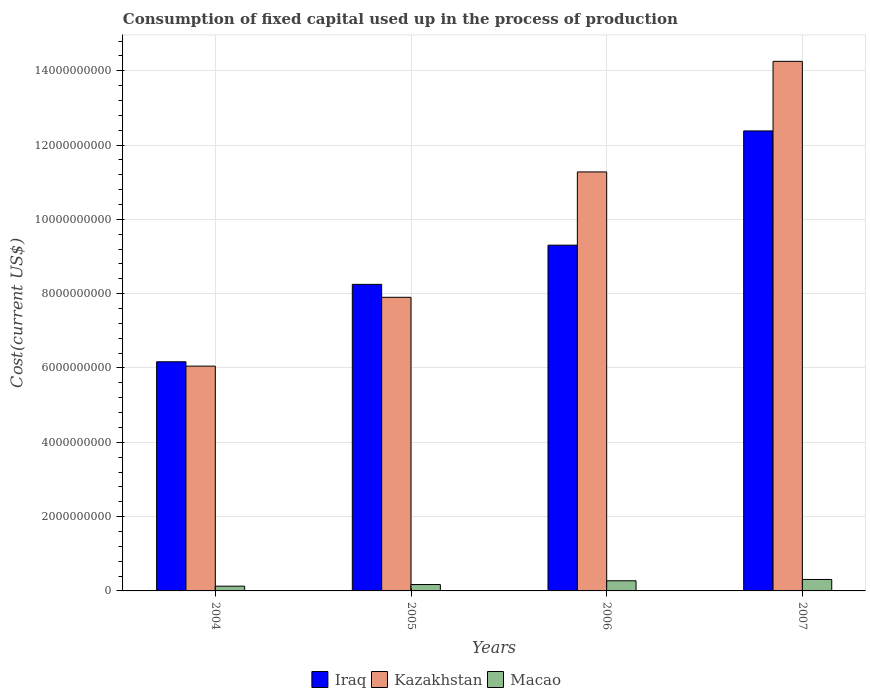How many different coloured bars are there?
Provide a short and direct response. 3. How many groups of bars are there?
Give a very brief answer. 4. How many bars are there on the 1st tick from the left?
Your answer should be compact. 3. How many bars are there on the 2nd tick from the right?
Provide a succinct answer. 3. What is the label of the 1st group of bars from the left?
Your answer should be very brief. 2004. What is the amount consumed in the process of production in Iraq in 2005?
Offer a terse response. 8.25e+09. Across all years, what is the maximum amount consumed in the process of production in Iraq?
Your response must be concise. 1.24e+1. Across all years, what is the minimum amount consumed in the process of production in Macao?
Make the answer very short. 1.28e+08. What is the total amount consumed in the process of production in Kazakhstan in the graph?
Your answer should be very brief. 3.95e+1. What is the difference between the amount consumed in the process of production in Macao in 2005 and that in 2007?
Your answer should be compact. -1.37e+08. What is the difference between the amount consumed in the process of production in Macao in 2006 and the amount consumed in the process of production in Kazakhstan in 2004?
Offer a very short reply. -5.78e+09. What is the average amount consumed in the process of production in Kazakhstan per year?
Offer a very short reply. 9.87e+09. In the year 2007, what is the difference between the amount consumed in the process of production in Macao and amount consumed in the process of production in Iraq?
Offer a very short reply. -1.21e+1. In how many years, is the amount consumed in the process of production in Kazakhstan greater than 4400000000 US$?
Your response must be concise. 4. What is the ratio of the amount consumed in the process of production in Iraq in 2005 to that in 2007?
Give a very brief answer. 0.67. Is the difference between the amount consumed in the process of production in Macao in 2005 and 2007 greater than the difference between the amount consumed in the process of production in Iraq in 2005 and 2007?
Give a very brief answer. Yes. What is the difference between the highest and the second highest amount consumed in the process of production in Macao?
Make the answer very short. 3.51e+07. What is the difference between the highest and the lowest amount consumed in the process of production in Kazakhstan?
Your answer should be very brief. 8.20e+09. In how many years, is the amount consumed in the process of production in Iraq greater than the average amount consumed in the process of production in Iraq taken over all years?
Keep it short and to the point. 2. What does the 3rd bar from the left in 2006 represents?
Make the answer very short. Macao. What does the 3rd bar from the right in 2005 represents?
Ensure brevity in your answer.  Iraq. How many bars are there?
Your answer should be compact. 12. What is the difference between two consecutive major ticks on the Y-axis?
Make the answer very short. 2.00e+09. Are the values on the major ticks of Y-axis written in scientific E-notation?
Provide a succinct answer. No. Does the graph contain grids?
Your response must be concise. Yes. Where does the legend appear in the graph?
Offer a very short reply. Bottom center. How many legend labels are there?
Make the answer very short. 3. What is the title of the graph?
Your answer should be compact. Consumption of fixed capital used up in the process of production. What is the label or title of the Y-axis?
Your answer should be very brief. Cost(current US$). What is the Cost(current US$) of Iraq in 2004?
Keep it short and to the point. 6.17e+09. What is the Cost(current US$) of Kazakhstan in 2004?
Your response must be concise. 6.05e+09. What is the Cost(current US$) of Macao in 2004?
Offer a terse response. 1.28e+08. What is the Cost(current US$) of Iraq in 2005?
Provide a short and direct response. 8.25e+09. What is the Cost(current US$) in Kazakhstan in 2005?
Provide a succinct answer. 7.90e+09. What is the Cost(current US$) in Macao in 2005?
Provide a short and direct response. 1.72e+08. What is the Cost(current US$) in Iraq in 2006?
Keep it short and to the point. 9.31e+09. What is the Cost(current US$) in Kazakhstan in 2006?
Offer a very short reply. 1.13e+1. What is the Cost(current US$) in Macao in 2006?
Your answer should be compact. 2.73e+08. What is the Cost(current US$) of Iraq in 2007?
Give a very brief answer. 1.24e+1. What is the Cost(current US$) in Kazakhstan in 2007?
Keep it short and to the point. 1.43e+1. What is the Cost(current US$) in Macao in 2007?
Make the answer very short. 3.08e+08. Across all years, what is the maximum Cost(current US$) of Iraq?
Give a very brief answer. 1.24e+1. Across all years, what is the maximum Cost(current US$) of Kazakhstan?
Offer a very short reply. 1.43e+1. Across all years, what is the maximum Cost(current US$) in Macao?
Your answer should be very brief. 3.08e+08. Across all years, what is the minimum Cost(current US$) in Iraq?
Your response must be concise. 6.17e+09. Across all years, what is the minimum Cost(current US$) of Kazakhstan?
Make the answer very short. 6.05e+09. Across all years, what is the minimum Cost(current US$) in Macao?
Your response must be concise. 1.28e+08. What is the total Cost(current US$) of Iraq in the graph?
Provide a succinct answer. 3.61e+1. What is the total Cost(current US$) of Kazakhstan in the graph?
Provide a succinct answer. 3.95e+1. What is the total Cost(current US$) of Macao in the graph?
Make the answer very short. 8.81e+08. What is the difference between the Cost(current US$) of Iraq in 2004 and that in 2005?
Ensure brevity in your answer.  -2.08e+09. What is the difference between the Cost(current US$) in Kazakhstan in 2004 and that in 2005?
Ensure brevity in your answer.  -1.85e+09. What is the difference between the Cost(current US$) in Macao in 2004 and that in 2005?
Give a very brief answer. -4.39e+07. What is the difference between the Cost(current US$) in Iraq in 2004 and that in 2006?
Keep it short and to the point. -3.14e+09. What is the difference between the Cost(current US$) in Kazakhstan in 2004 and that in 2006?
Make the answer very short. -5.23e+09. What is the difference between the Cost(current US$) in Macao in 2004 and that in 2006?
Offer a very short reply. -1.45e+08. What is the difference between the Cost(current US$) of Iraq in 2004 and that in 2007?
Your response must be concise. -6.21e+09. What is the difference between the Cost(current US$) in Kazakhstan in 2004 and that in 2007?
Give a very brief answer. -8.20e+09. What is the difference between the Cost(current US$) in Macao in 2004 and that in 2007?
Your answer should be very brief. -1.81e+08. What is the difference between the Cost(current US$) of Iraq in 2005 and that in 2006?
Keep it short and to the point. -1.05e+09. What is the difference between the Cost(current US$) in Kazakhstan in 2005 and that in 2006?
Give a very brief answer. -3.37e+09. What is the difference between the Cost(current US$) of Macao in 2005 and that in 2006?
Your answer should be compact. -1.02e+08. What is the difference between the Cost(current US$) in Iraq in 2005 and that in 2007?
Provide a succinct answer. -4.13e+09. What is the difference between the Cost(current US$) in Kazakhstan in 2005 and that in 2007?
Provide a short and direct response. -6.35e+09. What is the difference between the Cost(current US$) of Macao in 2005 and that in 2007?
Your answer should be very brief. -1.37e+08. What is the difference between the Cost(current US$) of Iraq in 2006 and that in 2007?
Give a very brief answer. -3.08e+09. What is the difference between the Cost(current US$) of Kazakhstan in 2006 and that in 2007?
Provide a short and direct response. -2.98e+09. What is the difference between the Cost(current US$) in Macao in 2006 and that in 2007?
Your answer should be very brief. -3.51e+07. What is the difference between the Cost(current US$) of Iraq in 2004 and the Cost(current US$) of Kazakhstan in 2005?
Give a very brief answer. -1.74e+09. What is the difference between the Cost(current US$) in Iraq in 2004 and the Cost(current US$) in Macao in 2005?
Your answer should be compact. 6.00e+09. What is the difference between the Cost(current US$) of Kazakhstan in 2004 and the Cost(current US$) of Macao in 2005?
Your answer should be very brief. 5.88e+09. What is the difference between the Cost(current US$) of Iraq in 2004 and the Cost(current US$) of Kazakhstan in 2006?
Provide a short and direct response. -5.11e+09. What is the difference between the Cost(current US$) of Iraq in 2004 and the Cost(current US$) of Macao in 2006?
Provide a succinct answer. 5.89e+09. What is the difference between the Cost(current US$) in Kazakhstan in 2004 and the Cost(current US$) in Macao in 2006?
Your answer should be very brief. 5.78e+09. What is the difference between the Cost(current US$) in Iraq in 2004 and the Cost(current US$) in Kazakhstan in 2007?
Provide a short and direct response. -8.09e+09. What is the difference between the Cost(current US$) in Iraq in 2004 and the Cost(current US$) in Macao in 2007?
Your answer should be compact. 5.86e+09. What is the difference between the Cost(current US$) in Kazakhstan in 2004 and the Cost(current US$) in Macao in 2007?
Provide a succinct answer. 5.74e+09. What is the difference between the Cost(current US$) of Iraq in 2005 and the Cost(current US$) of Kazakhstan in 2006?
Provide a short and direct response. -3.03e+09. What is the difference between the Cost(current US$) in Iraq in 2005 and the Cost(current US$) in Macao in 2006?
Your response must be concise. 7.98e+09. What is the difference between the Cost(current US$) in Kazakhstan in 2005 and the Cost(current US$) in Macao in 2006?
Offer a terse response. 7.63e+09. What is the difference between the Cost(current US$) of Iraq in 2005 and the Cost(current US$) of Kazakhstan in 2007?
Give a very brief answer. -6.00e+09. What is the difference between the Cost(current US$) of Iraq in 2005 and the Cost(current US$) of Macao in 2007?
Provide a succinct answer. 7.94e+09. What is the difference between the Cost(current US$) in Kazakhstan in 2005 and the Cost(current US$) in Macao in 2007?
Offer a terse response. 7.59e+09. What is the difference between the Cost(current US$) in Iraq in 2006 and the Cost(current US$) in Kazakhstan in 2007?
Your answer should be very brief. -4.95e+09. What is the difference between the Cost(current US$) of Iraq in 2006 and the Cost(current US$) of Macao in 2007?
Keep it short and to the point. 9.00e+09. What is the difference between the Cost(current US$) of Kazakhstan in 2006 and the Cost(current US$) of Macao in 2007?
Provide a succinct answer. 1.10e+1. What is the average Cost(current US$) of Iraq per year?
Provide a succinct answer. 9.03e+09. What is the average Cost(current US$) of Kazakhstan per year?
Give a very brief answer. 9.87e+09. What is the average Cost(current US$) of Macao per year?
Your answer should be compact. 2.20e+08. In the year 2004, what is the difference between the Cost(current US$) of Iraq and Cost(current US$) of Kazakhstan?
Offer a terse response. 1.17e+08. In the year 2004, what is the difference between the Cost(current US$) of Iraq and Cost(current US$) of Macao?
Give a very brief answer. 6.04e+09. In the year 2004, what is the difference between the Cost(current US$) of Kazakhstan and Cost(current US$) of Macao?
Keep it short and to the point. 5.92e+09. In the year 2005, what is the difference between the Cost(current US$) in Iraq and Cost(current US$) in Kazakhstan?
Ensure brevity in your answer.  3.48e+08. In the year 2005, what is the difference between the Cost(current US$) in Iraq and Cost(current US$) in Macao?
Your response must be concise. 8.08e+09. In the year 2005, what is the difference between the Cost(current US$) in Kazakhstan and Cost(current US$) in Macao?
Provide a succinct answer. 7.73e+09. In the year 2006, what is the difference between the Cost(current US$) of Iraq and Cost(current US$) of Kazakhstan?
Keep it short and to the point. -1.97e+09. In the year 2006, what is the difference between the Cost(current US$) in Iraq and Cost(current US$) in Macao?
Offer a terse response. 9.03e+09. In the year 2006, what is the difference between the Cost(current US$) in Kazakhstan and Cost(current US$) in Macao?
Offer a terse response. 1.10e+1. In the year 2007, what is the difference between the Cost(current US$) of Iraq and Cost(current US$) of Kazakhstan?
Your answer should be very brief. -1.87e+09. In the year 2007, what is the difference between the Cost(current US$) in Iraq and Cost(current US$) in Macao?
Offer a very short reply. 1.21e+1. In the year 2007, what is the difference between the Cost(current US$) of Kazakhstan and Cost(current US$) of Macao?
Ensure brevity in your answer.  1.39e+1. What is the ratio of the Cost(current US$) of Iraq in 2004 to that in 2005?
Your response must be concise. 0.75. What is the ratio of the Cost(current US$) of Kazakhstan in 2004 to that in 2005?
Give a very brief answer. 0.77. What is the ratio of the Cost(current US$) of Macao in 2004 to that in 2005?
Offer a terse response. 0.74. What is the ratio of the Cost(current US$) in Iraq in 2004 to that in 2006?
Your answer should be very brief. 0.66. What is the ratio of the Cost(current US$) in Kazakhstan in 2004 to that in 2006?
Give a very brief answer. 0.54. What is the ratio of the Cost(current US$) of Macao in 2004 to that in 2006?
Keep it short and to the point. 0.47. What is the ratio of the Cost(current US$) of Iraq in 2004 to that in 2007?
Your answer should be compact. 0.5. What is the ratio of the Cost(current US$) of Kazakhstan in 2004 to that in 2007?
Your answer should be very brief. 0.42. What is the ratio of the Cost(current US$) in Macao in 2004 to that in 2007?
Your answer should be very brief. 0.41. What is the ratio of the Cost(current US$) in Iraq in 2005 to that in 2006?
Give a very brief answer. 0.89. What is the ratio of the Cost(current US$) in Kazakhstan in 2005 to that in 2006?
Offer a terse response. 0.7. What is the ratio of the Cost(current US$) of Macao in 2005 to that in 2006?
Provide a short and direct response. 0.63. What is the ratio of the Cost(current US$) of Iraq in 2005 to that in 2007?
Your answer should be compact. 0.67. What is the ratio of the Cost(current US$) in Kazakhstan in 2005 to that in 2007?
Offer a terse response. 0.55. What is the ratio of the Cost(current US$) of Macao in 2005 to that in 2007?
Make the answer very short. 0.56. What is the ratio of the Cost(current US$) in Iraq in 2006 to that in 2007?
Provide a short and direct response. 0.75. What is the ratio of the Cost(current US$) of Kazakhstan in 2006 to that in 2007?
Your answer should be compact. 0.79. What is the ratio of the Cost(current US$) in Macao in 2006 to that in 2007?
Offer a very short reply. 0.89. What is the difference between the highest and the second highest Cost(current US$) in Iraq?
Give a very brief answer. 3.08e+09. What is the difference between the highest and the second highest Cost(current US$) in Kazakhstan?
Your answer should be very brief. 2.98e+09. What is the difference between the highest and the second highest Cost(current US$) of Macao?
Offer a very short reply. 3.51e+07. What is the difference between the highest and the lowest Cost(current US$) of Iraq?
Provide a short and direct response. 6.21e+09. What is the difference between the highest and the lowest Cost(current US$) in Kazakhstan?
Make the answer very short. 8.20e+09. What is the difference between the highest and the lowest Cost(current US$) of Macao?
Provide a succinct answer. 1.81e+08. 